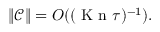<formula> <loc_0><loc_0><loc_500><loc_500>\| \mathcal { C } \| = O ( ( { K n } \tau ) ^ { - 1 } ) .</formula> 